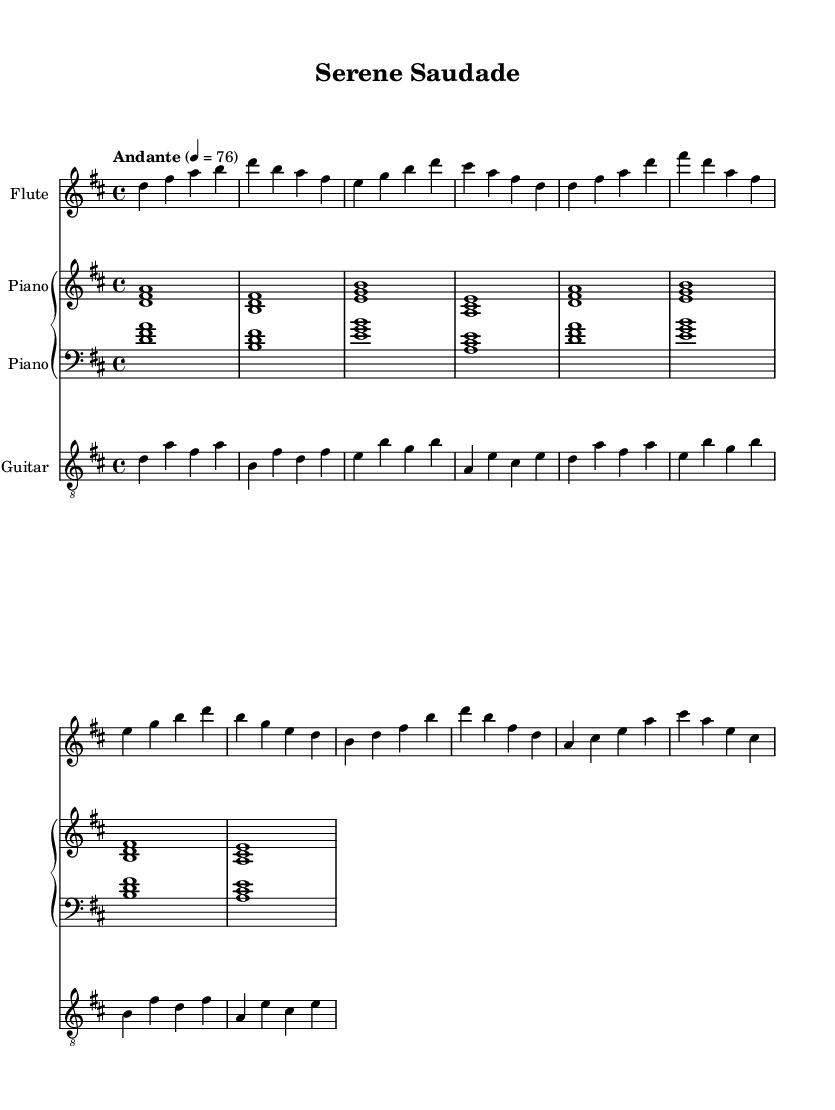What is the key signature of this music? The key signature is D major, which has two sharps: F# and C#.
Answer: D major What is the time signature of this music? The time signature is 4/4, indicating four beats per measure with a quarter note receiving one beat.
Answer: 4/4 What is the tempo marking of this piece? The tempo marking indicates "Andante" with a metronome marking of 76 beats per minute, suggesting a moderately slow pace.
Answer: Andante Which instrument is playing the melody in the intro? The flute is designated to play the melody in the intro, as indicated by the notation for the flute staff being the first in the score.
Answer: Flute How many measures are there in the A Section? The A Section consists of two measures, which are indicated by the grouping of notes for that section on the score.
Answer: 2 What is the harmonic structure of the B Section based on the chords indicated for the piano? The B Section primarily outlines the harmony using a pattern of two triads, showing a relationship between the selected notes which constructs a sequence of harmonies.
Answer: Two triads Is this composition more aligned with traditional jazz or bossa nova? The composition leans more towards bossa nova, as this style is characterized by its soft melodies and harmonic sophistication that blend Brazilian and jazz elements.
Answer: Bossa nova 